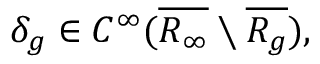Convert formula to latex. <formula><loc_0><loc_0><loc_500><loc_500>\delta _ { g } \in C ^ { \infty } ( \overline { { R _ { \infty } } } \ \overline { { R _ { g } } } ) ,</formula> 